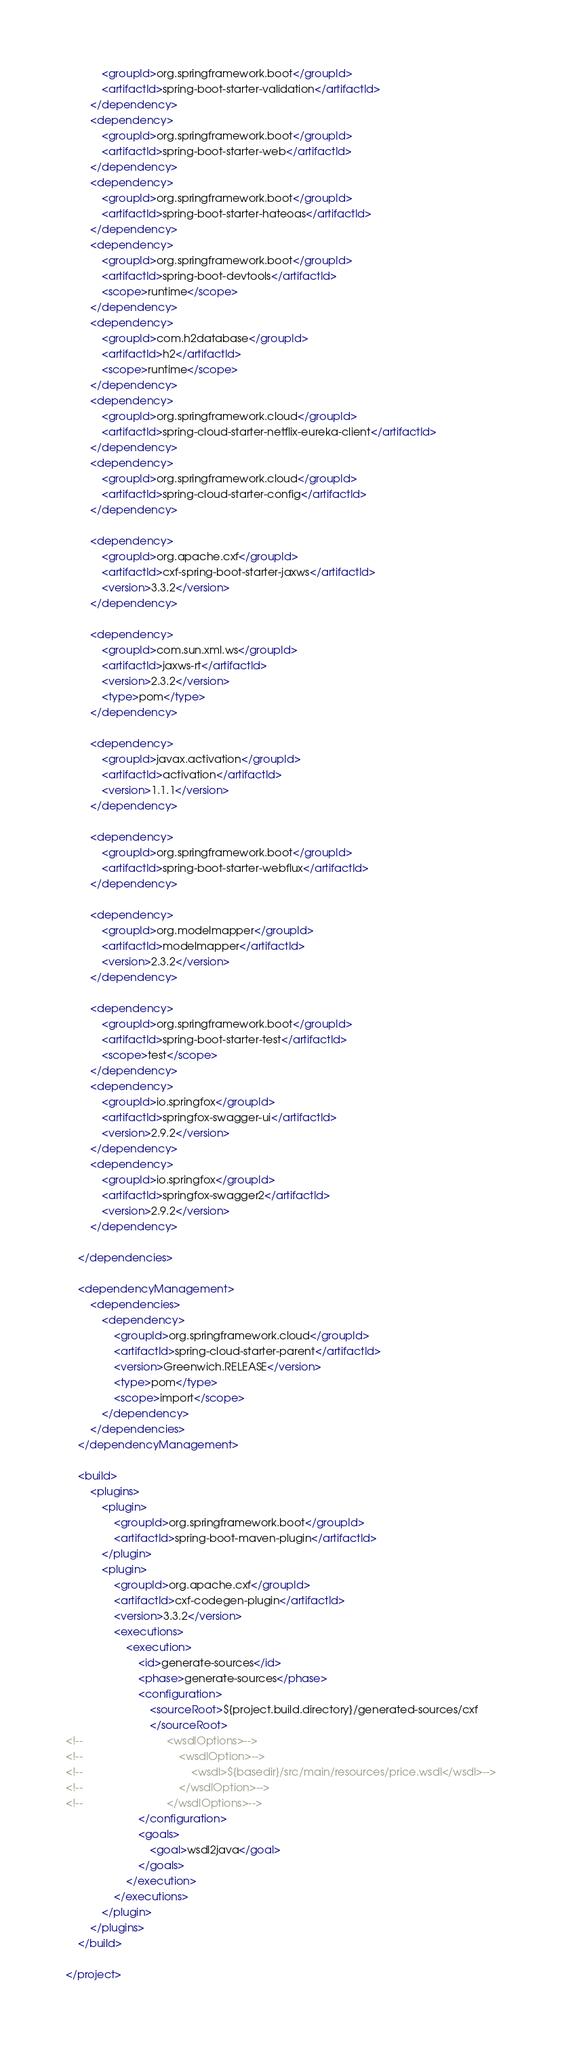<code> <loc_0><loc_0><loc_500><loc_500><_XML_>            <groupId>org.springframework.boot</groupId>
            <artifactId>spring-boot-starter-validation</artifactId>
        </dependency>
        <dependency>
            <groupId>org.springframework.boot</groupId>
            <artifactId>spring-boot-starter-web</artifactId>
        </dependency>
        <dependency>
            <groupId>org.springframework.boot</groupId>
            <artifactId>spring-boot-starter-hateoas</artifactId>
        </dependency>
        <dependency>
            <groupId>org.springframework.boot</groupId>
            <artifactId>spring-boot-devtools</artifactId>
            <scope>runtime</scope>
        </dependency>
        <dependency>
            <groupId>com.h2database</groupId>
            <artifactId>h2</artifactId>
            <scope>runtime</scope>
        </dependency>
        <dependency>
            <groupId>org.springframework.cloud</groupId>
            <artifactId>spring-cloud-starter-netflix-eureka-client</artifactId>
        </dependency>
        <dependency>
            <groupId>org.springframework.cloud</groupId>
            <artifactId>spring-cloud-starter-config</artifactId>
        </dependency>

        <dependency>
            <groupId>org.apache.cxf</groupId>
            <artifactId>cxf-spring-boot-starter-jaxws</artifactId>
            <version>3.3.2</version>
        </dependency>

        <dependency>
            <groupId>com.sun.xml.ws</groupId>
            <artifactId>jaxws-rt</artifactId>
            <version>2.3.2</version>
            <type>pom</type>
        </dependency>

        <dependency>
            <groupId>javax.activation</groupId>
            <artifactId>activation</artifactId>
            <version>1.1.1</version>
        </dependency>

        <dependency>
            <groupId>org.springframework.boot</groupId>
            <artifactId>spring-boot-starter-webflux</artifactId>
        </dependency>

        <dependency>
            <groupId>org.modelmapper</groupId>
            <artifactId>modelmapper</artifactId>
            <version>2.3.2</version>
        </dependency>

        <dependency>
            <groupId>org.springframework.boot</groupId>
            <artifactId>spring-boot-starter-test</artifactId>
            <scope>test</scope>
        </dependency>
        <dependency>
            <groupId>io.springfox</groupId>
            <artifactId>springfox-swagger-ui</artifactId>
            <version>2.9.2</version>
        </dependency>
        <dependency>
            <groupId>io.springfox</groupId>
            <artifactId>springfox-swagger2</artifactId>
            <version>2.9.2</version>
        </dependency>

    </dependencies>

    <dependencyManagement>
        <dependencies>
            <dependency>
                <groupId>org.springframework.cloud</groupId>
                <artifactId>spring-cloud-starter-parent</artifactId>
                <version>Greenwich.RELEASE</version>
                <type>pom</type>
                <scope>import</scope>
            </dependency>
        </dependencies>
    </dependencyManagement>

    <build>
        <plugins>
            <plugin>
                <groupId>org.springframework.boot</groupId>
                <artifactId>spring-boot-maven-plugin</artifactId>
            </plugin>
            <plugin>
                <groupId>org.apache.cxf</groupId>
                <artifactId>cxf-codegen-plugin</artifactId>
                <version>3.3.2</version>
                <executions>
                    <execution>
                        <id>generate-sources</id>
                        <phase>generate-sources</phase>
                        <configuration>
                            <sourceRoot>${project.build.directory}/generated-sources/cxf
                            </sourceRoot>
<!--                            <wsdlOptions>-->
<!--                                <wsdlOption>-->
<!--                                    <wsdl>${basedir}/src/main/resources/price.wsdl</wsdl>-->
<!--                                </wsdlOption>-->
<!--                            </wsdlOptions>-->
                        </configuration>
                        <goals>
                            <goal>wsdl2java</goal>
                        </goals>
                    </execution>
                </executions>
            </plugin>
        </plugins>
    </build>

</project>
</code> 